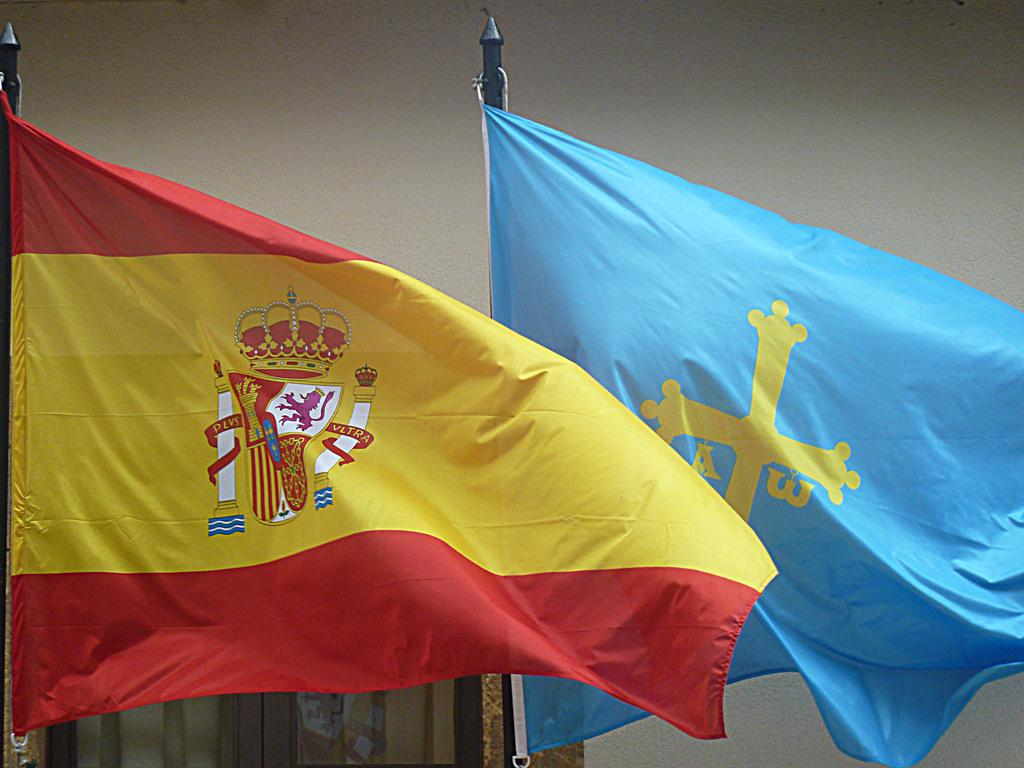How many flags are visible in the image? There are two flags in the image. Where are the flags located in relation to other objects in the image? The flags are in front of a wall. Who is the owner of the cap in the image? There is no cap present in the image, so it is not possible to determine the owner. 